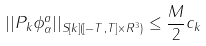<formula> <loc_0><loc_0><loc_500><loc_500>| | P _ { k } \phi ^ { a } _ { \alpha } | | _ { S [ k ] ( [ - T , T ] \times R ^ { 3 } ) } \leq \frac { M } { 2 } c _ { k }</formula> 